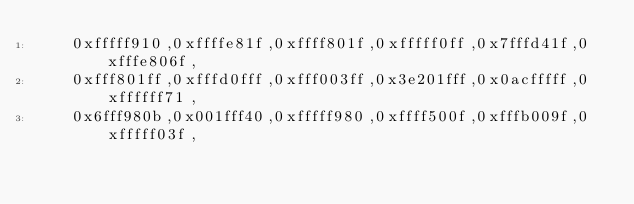Convert code to text. <code><loc_0><loc_0><loc_500><loc_500><_C++_>    0xfffff910,0xffffe81f,0xffff801f,0xfffff0ff,0x7fffd41f,0xfffe806f,
    0xfff801ff,0xfffd0fff,0xfff003ff,0x3e201fff,0x0acfffff,0xffffff71,
    0x6fff980b,0x001fff40,0xfffff980,0xffff500f,0xfffb009f,0xfffff03f,</code> 